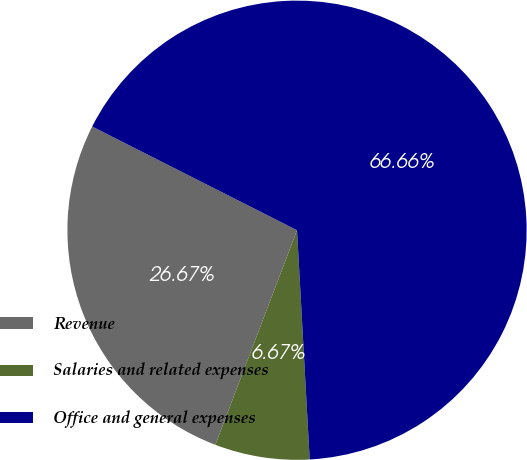Convert chart. <chart><loc_0><loc_0><loc_500><loc_500><pie_chart><fcel>Revenue<fcel>Salaries and related expenses<fcel>Office and general expenses<nl><fcel>26.67%<fcel>6.67%<fcel>66.67%<nl></chart> 